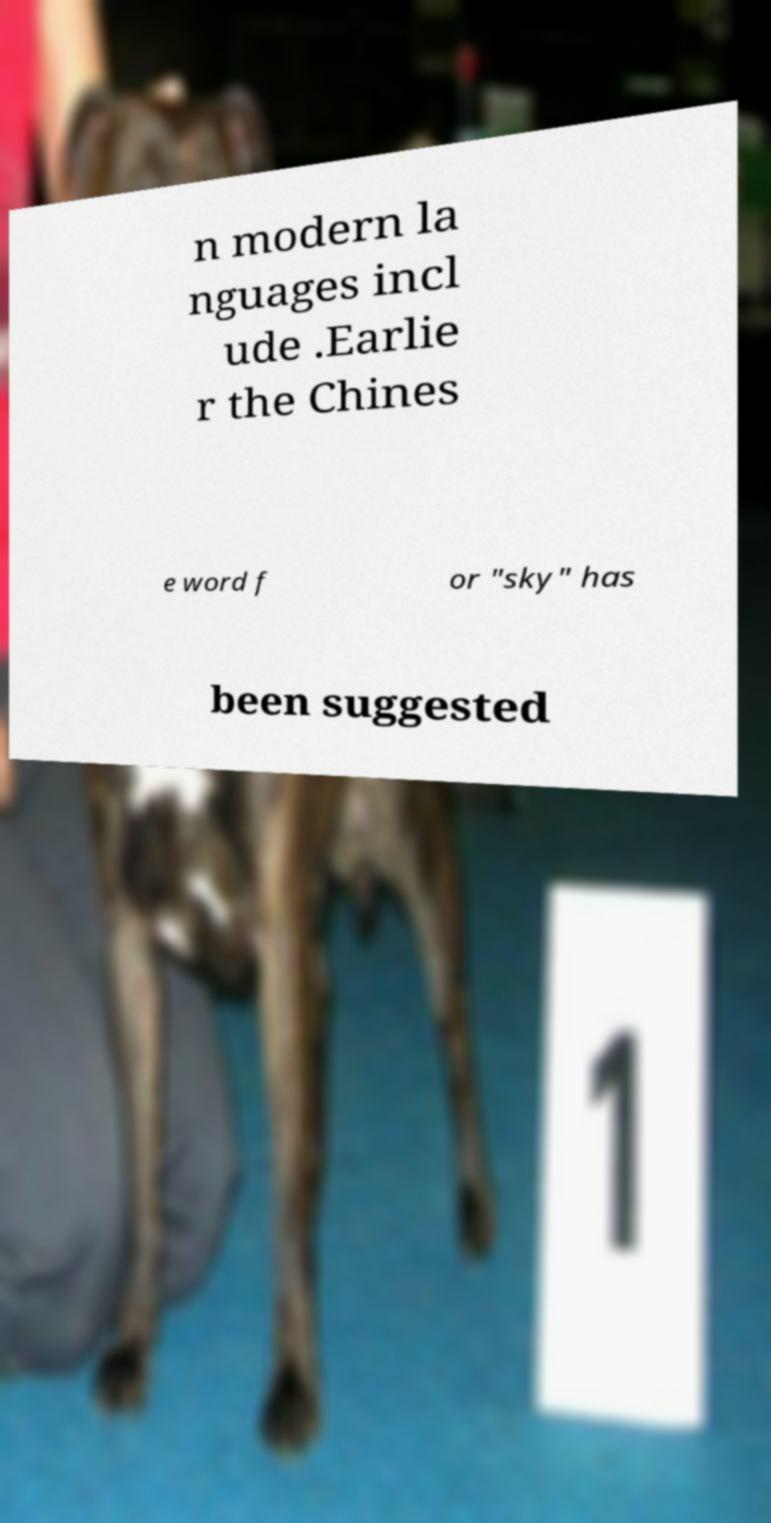For documentation purposes, I need the text within this image transcribed. Could you provide that? n modern la nguages incl ude .Earlie r the Chines e word f or "sky" has been suggested 